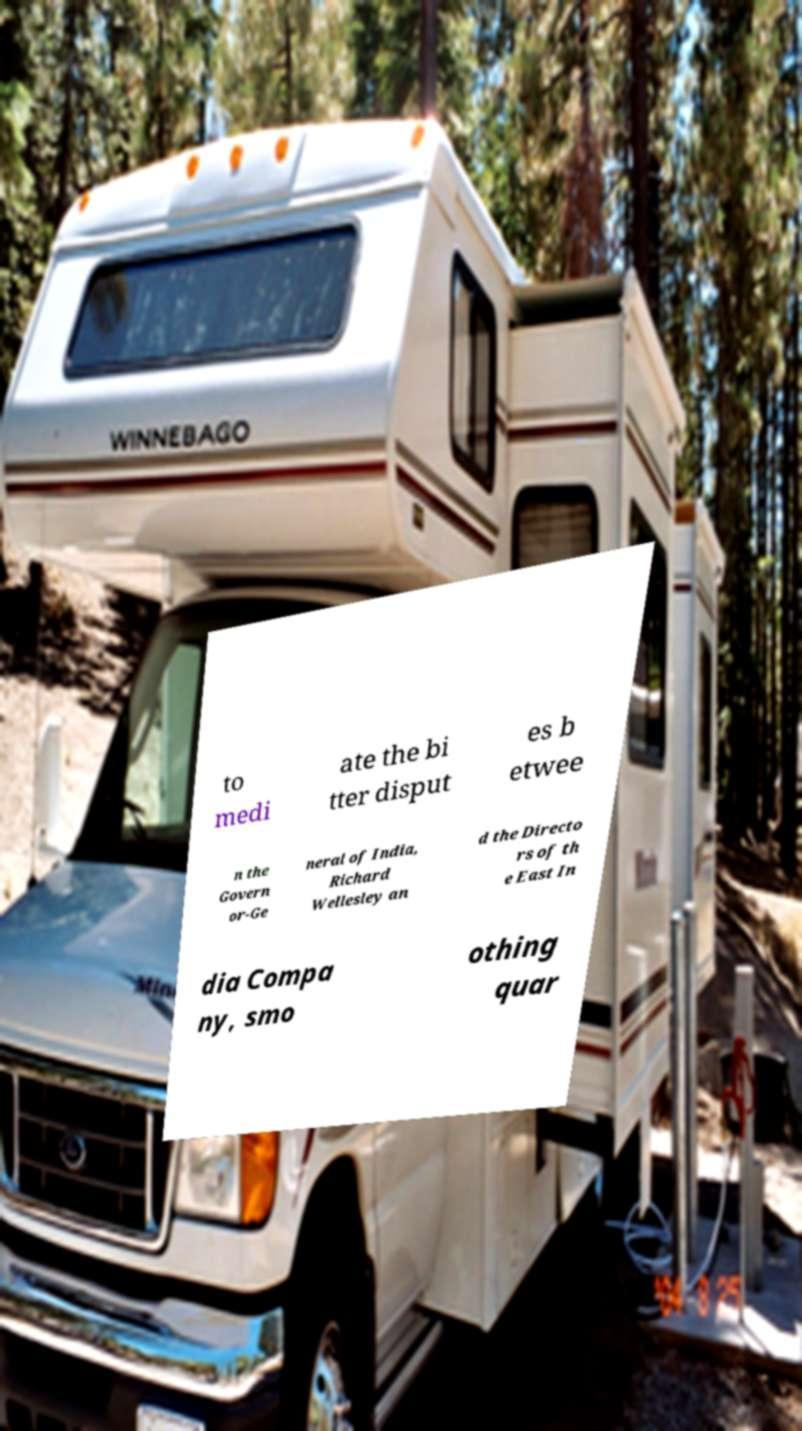What messages or text are displayed in this image? I need them in a readable, typed format. to medi ate the bi tter disput es b etwee n the Govern or-Ge neral of India, Richard Wellesley an d the Directo rs of th e East In dia Compa ny, smo othing quar 